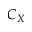<formula> <loc_0><loc_0><loc_500><loc_500>C _ { X }</formula> 